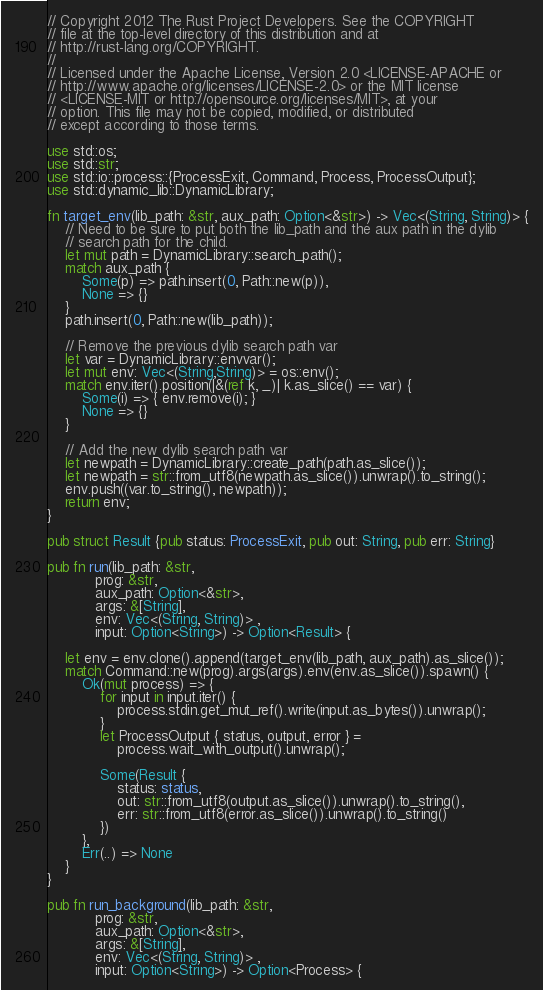Convert code to text. <code><loc_0><loc_0><loc_500><loc_500><_Rust_>// Copyright 2012 The Rust Project Developers. See the COPYRIGHT
// file at the top-level directory of this distribution and at
// http://rust-lang.org/COPYRIGHT.
//
// Licensed under the Apache License, Version 2.0 <LICENSE-APACHE or
// http://www.apache.org/licenses/LICENSE-2.0> or the MIT license
// <LICENSE-MIT or http://opensource.org/licenses/MIT>, at your
// option. This file may not be copied, modified, or distributed
// except according to those terms.

use std::os;
use std::str;
use std::io::process::{ProcessExit, Command, Process, ProcessOutput};
use std::dynamic_lib::DynamicLibrary;

fn target_env(lib_path: &str, aux_path: Option<&str>) -> Vec<(String, String)> {
    // Need to be sure to put both the lib_path and the aux path in the dylib
    // search path for the child.
    let mut path = DynamicLibrary::search_path();
    match aux_path {
        Some(p) => path.insert(0, Path::new(p)),
        None => {}
    }
    path.insert(0, Path::new(lib_path));

    // Remove the previous dylib search path var
    let var = DynamicLibrary::envvar();
    let mut env: Vec<(String,String)> = os::env();
    match env.iter().position(|&(ref k, _)| k.as_slice() == var) {
        Some(i) => { env.remove(i); }
        None => {}
    }

    // Add the new dylib search path var
    let newpath = DynamicLibrary::create_path(path.as_slice());
    let newpath = str::from_utf8(newpath.as_slice()).unwrap().to_string();
    env.push((var.to_string(), newpath));
    return env;
}

pub struct Result {pub status: ProcessExit, pub out: String, pub err: String}

pub fn run(lib_path: &str,
           prog: &str,
           aux_path: Option<&str>,
           args: &[String],
           env: Vec<(String, String)> ,
           input: Option<String>) -> Option<Result> {

    let env = env.clone().append(target_env(lib_path, aux_path).as_slice());
    match Command::new(prog).args(args).env(env.as_slice()).spawn() {
        Ok(mut process) => {
            for input in input.iter() {
                process.stdin.get_mut_ref().write(input.as_bytes()).unwrap();
            }
            let ProcessOutput { status, output, error } =
                process.wait_with_output().unwrap();

            Some(Result {
                status: status,
                out: str::from_utf8(output.as_slice()).unwrap().to_string(),
                err: str::from_utf8(error.as_slice()).unwrap().to_string()
            })
        },
        Err(..) => None
    }
}

pub fn run_background(lib_path: &str,
           prog: &str,
           aux_path: Option<&str>,
           args: &[String],
           env: Vec<(String, String)> ,
           input: Option<String>) -> Option<Process> {
</code> 